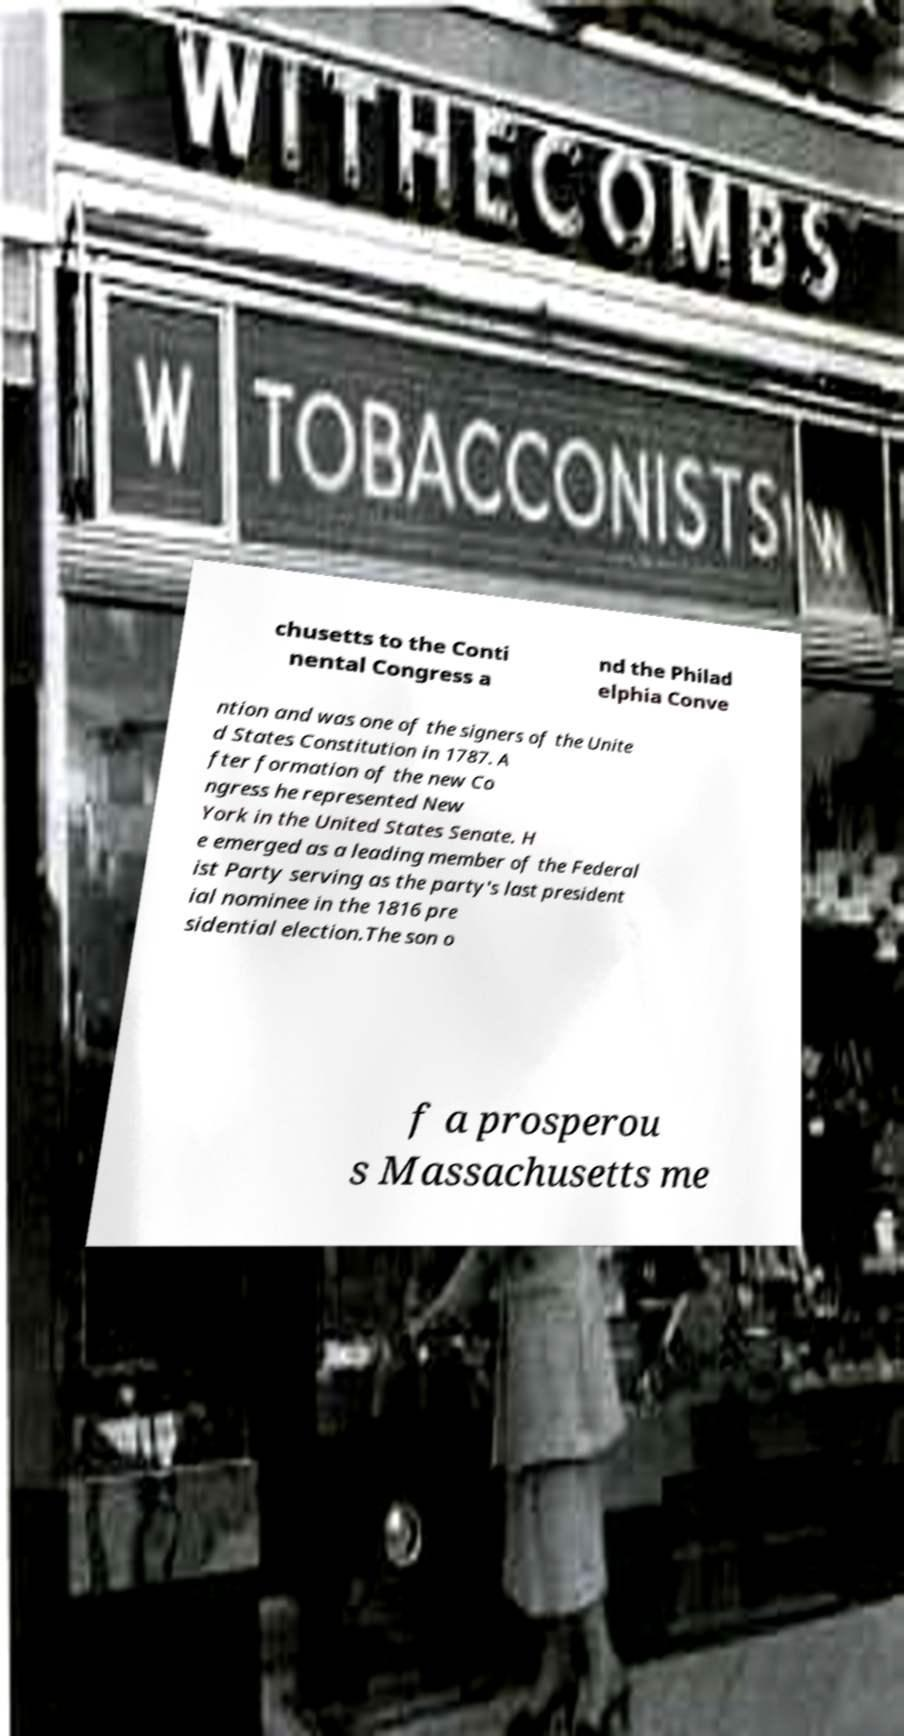For documentation purposes, I need the text within this image transcribed. Could you provide that? chusetts to the Conti nental Congress a nd the Philad elphia Conve ntion and was one of the signers of the Unite d States Constitution in 1787. A fter formation of the new Co ngress he represented New York in the United States Senate. H e emerged as a leading member of the Federal ist Party serving as the party's last president ial nominee in the 1816 pre sidential election.The son o f a prosperou s Massachusetts me 